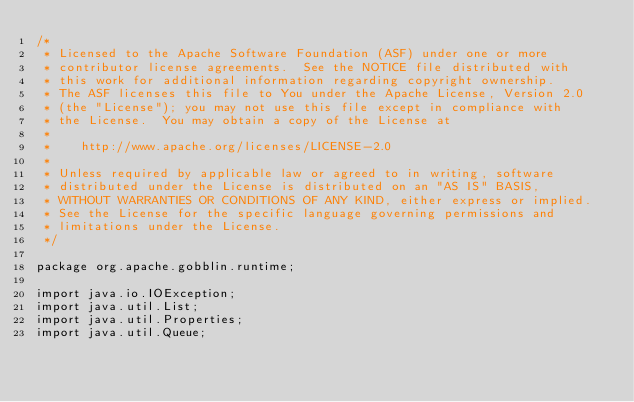<code> <loc_0><loc_0><loc_500><loc_500><_Java_>/*
 * Licensed to the Apache Software Foundation (ASF) under one or more
 * contributor license agreements.  See the NOTICE file distributed with
 * this work for additional information regarding copyright ownership.
 * The ASF licenses this file to You under the Apache License, Version 2.0
 * (the "License"); you may not use this file except in compliance with
 * the License.  You may obtain a copy of the License at
 *
 *    http://www.apache.org/licenses/LICENSE-2.0
 *
 * Unless required by applicable law or agreed to in writing, software
 * distributed under the License is distributed on an "AS IS" BASIS,
 * WITHOUT WARRANTIES OR CONDITIONS OF ANY KIND, either express or implied.
 * See the License for the specific language governing permissions and
 * limitations under the License.
 */

package org.apache.gobblin.runtime;

import java.io.IOException;
import java.util.List;
import java.util.Properties;
import java.util.Queue;</code> 